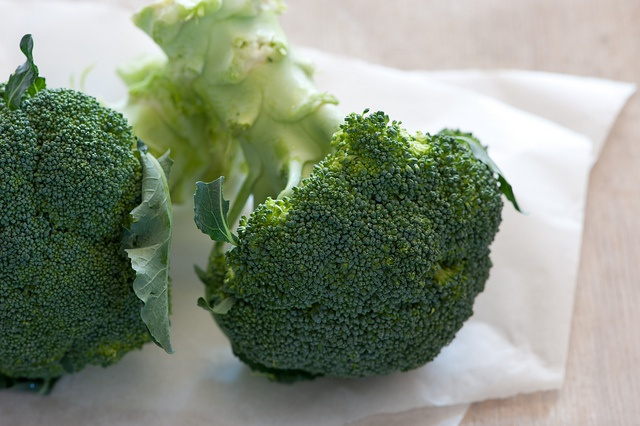Describe the objects in this image and their specific colors. I can see broccoli in lavender, black, and darkgreen tones and broccoli in lavender, black, darkgreen, and teal tones in this image. 